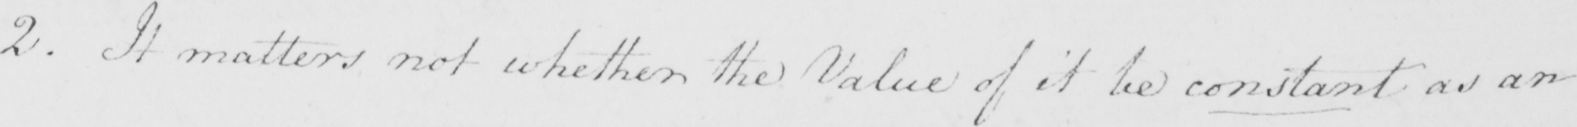Please transcribe the handwritten text in this image. 2 . It mattes not whether the Value of it be constant as an 